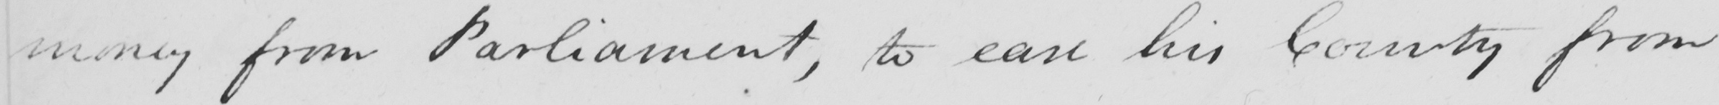Can you tell me what this handwritten text says? money from Parliament , to ease his County from 